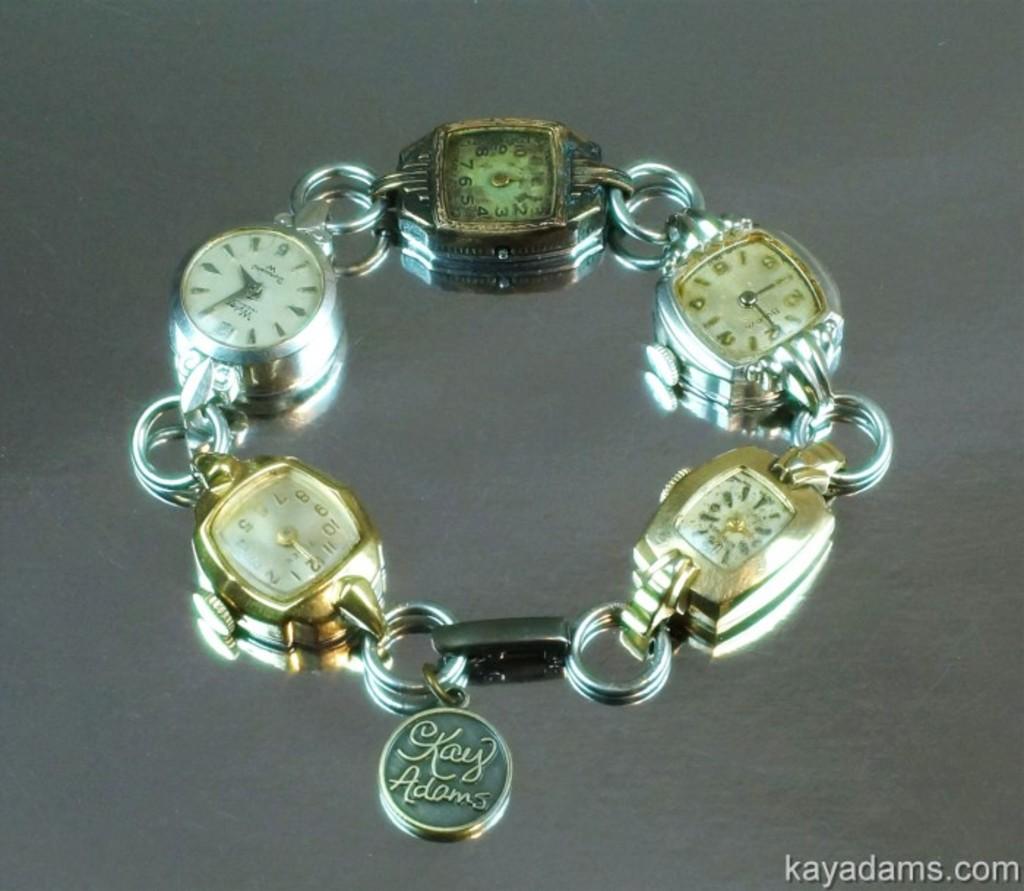Who does this braclet belong to?
Offer a very short reply. Kay adams. What is the website on this image?
Your answer should be very brief. Kayadams.com. 